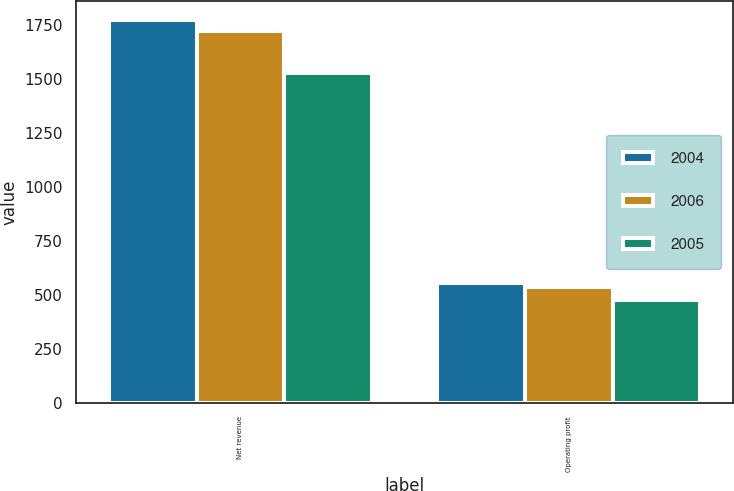Convert chart. <chart><loc_0><loc_0><loc_500><loc_500><stacked_bar_chart><ecel><fcel>Net revenue<fcel>Operating profit<nl><fcel>2004<fcel>1769<fcel>554<nl><fcel>2006<fcel>1718<fcel>537<nl><fcel>2005<fcel>1526<fcel>475<nl></chart> 